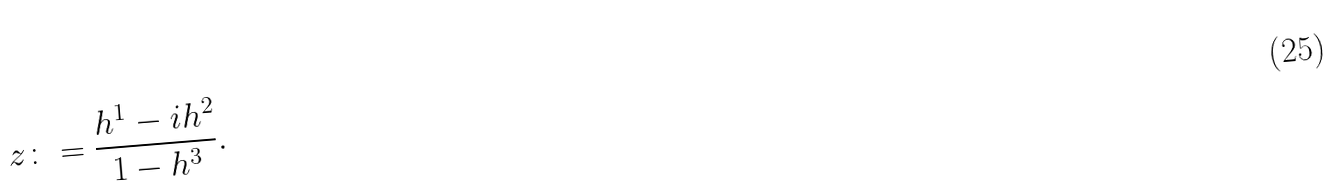Convert formula to latex. <formula><loc_0><loc_0><loc_500><loc_500>z \colon = \frac { h ^ { 1 } - i h ^ { 2 } } { 1 - h ^ { 3 } } .</formula> 